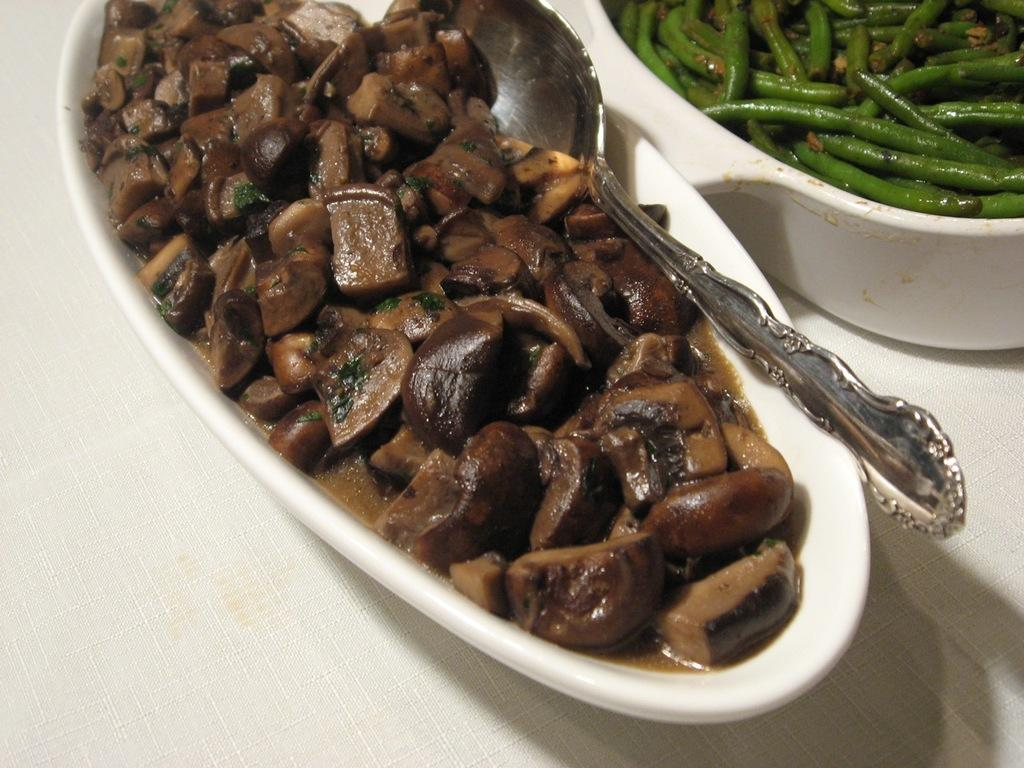What type of containers are present in the image? There are bowls containing food in the image. What utensils are visible in the image? Spoons are visible in the image. Where are the bowls and spoons located? The bowls and spoons are placed on a surface. Can you hear the bells ringing in the image? There are no bells present in the image, so it is not possible to hear them ringing. 